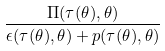Convert formula to latex. <formula><loc_0><loc_0><loc_500><loc_500>\frac { \Pi ( \tau ( \theta ) , \theta ) } { \epsilon ( \tau ( \theta ) , \theta ) + p ( \tau ( \theta ) , \theta ) }</formula> 